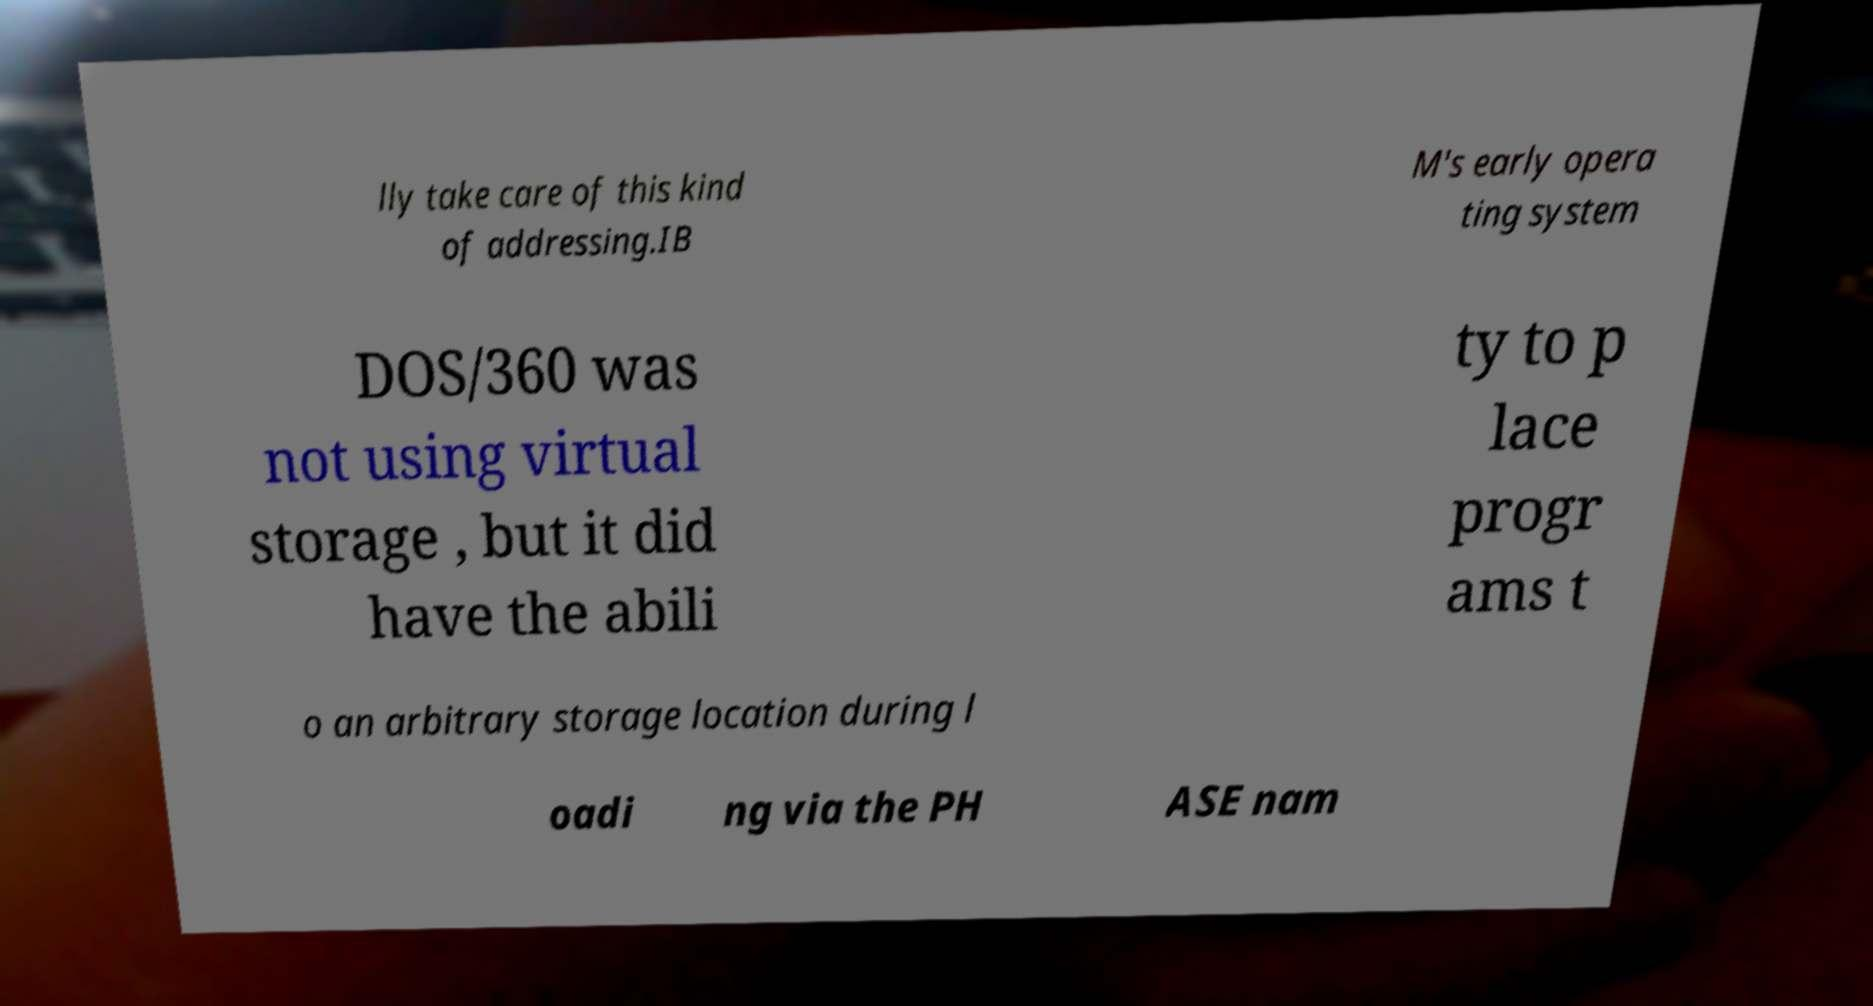I need the written content from this picture converted into text. Can you do that? lly take care of this kind of addressing.IB M's early opera ting system DOS/360 was not using virtual storage , but it did have the abili ty to p lace progr ams t o an arbitrary storage location during l oadi ng via the PH ASE nam 